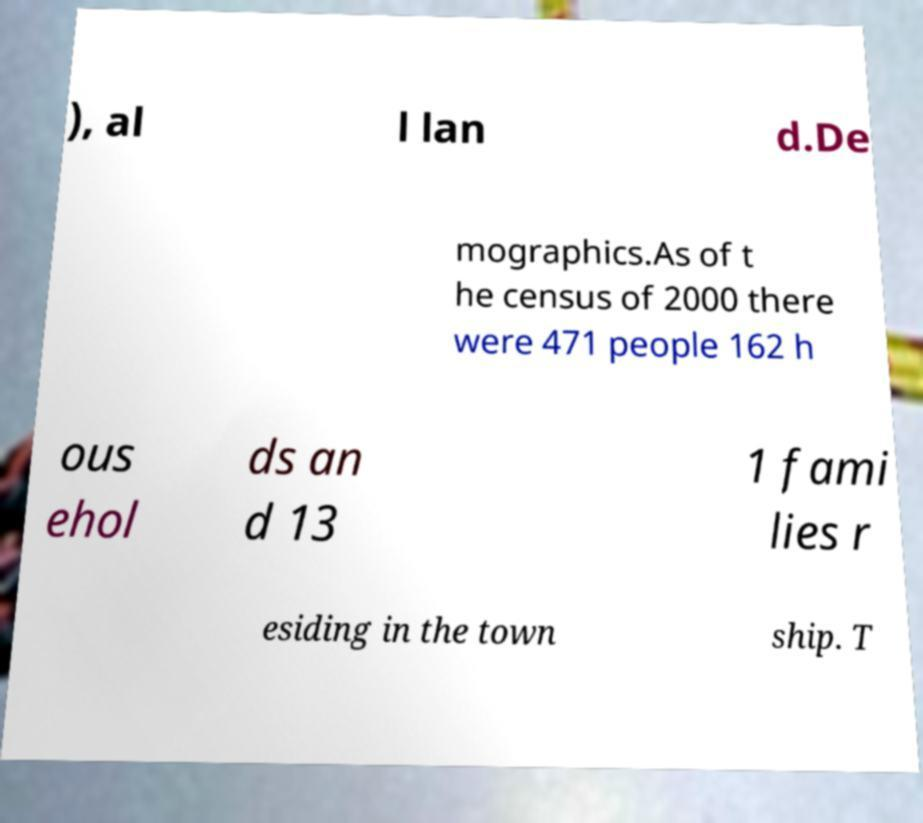Could you extract and type out the text from this image? ), al l lan d.De mographics.As of t he census of 2000 there were 471 people 162 h ous ehol ds an d 13 1 fami lies r esiding in the town ship. T 